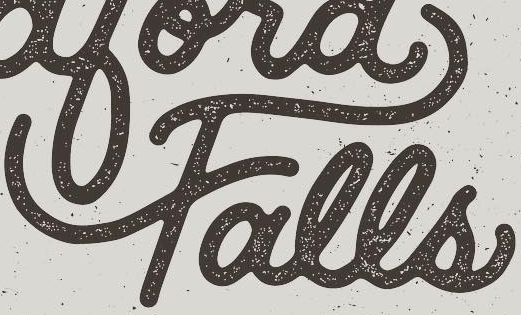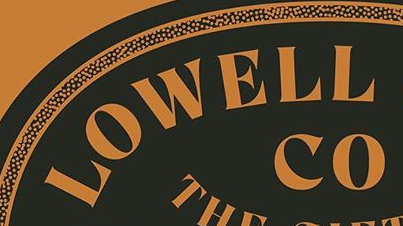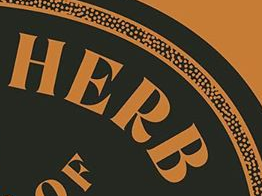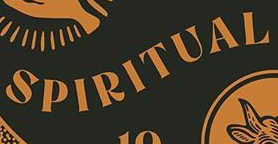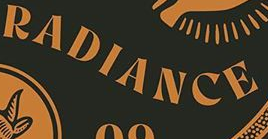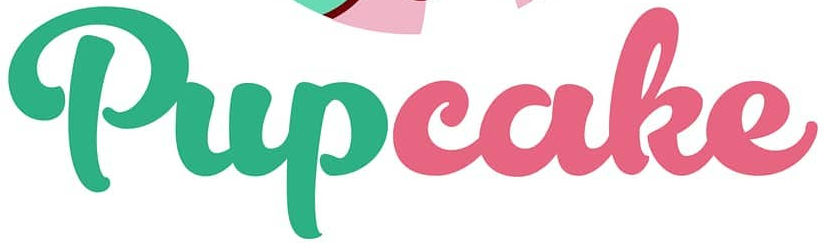What text appears in these images from left to right, separated by a semicolon? Falls; LOWELL; HERB; SPIRITUAL; RADIANCE; Pupcake 